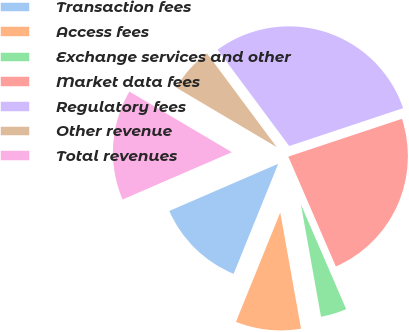Convert chart. <chart><loc_0><loc_0><loc_500><loc_500><pie_chart><fcel>Transaction fees<fcel>Access fees<fcel>Exchange services and other<fcel>Market data fees<fcel>Regulatory fees<fcel>Other revenue<fcel>Total revenues<nl><fcel>12.37%<fcel>8.95%<fcel>3.68%<fcel>23.61%<fcel>30.06%<fcel>6.32%<fcel>15.01%<nl></chart> 